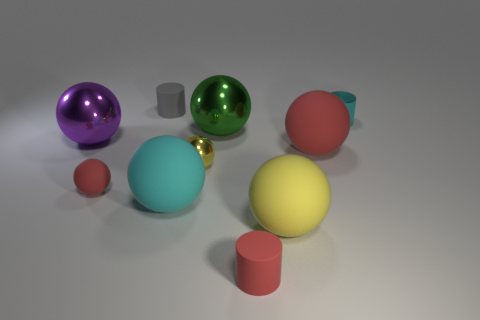What is the shape of the small metallic object left of the cyan thing to the right of the big yellow sphere that is behind the tiny red cylinder?
Ensure brevity in your answer.  Sphere. What is the shape of the cyan shiny thing?
Make the answer very short. Cylinder. What is the color of the small ball that is behind the tiny matte sphere?
Make the answer very short. Yellow. There is a matte thing that is behind the shiny cylinder; does it have the same size as the tiny red matte cylinder?
Offer a very short reply. Yes. The purple metal thing that is the same shape as the large green object is what size?
Ensure brevity in your answer.  Large. Is there any other thing that has the same size as the yellow shiny sphere?
Your answer should be compact. Yes. Is the shape of the yellow matte thing the same as the tiny yellow thing?
Your response must be concise. Yes. Are there fewer big purple metal balls right of the tiny cyan metallic cylinder than large red matte objects in front of the big yellow rubber sphere?
Make the answer very short. No. What number of tiny metal cylinders are left of the small rubber sphere?
Make the answer very short. 0. There is a tiny cyan object right of the gray object; is it the same shape as the big green metallic thing that is behind the large purple sphere?
Your answer should be compact. No. 